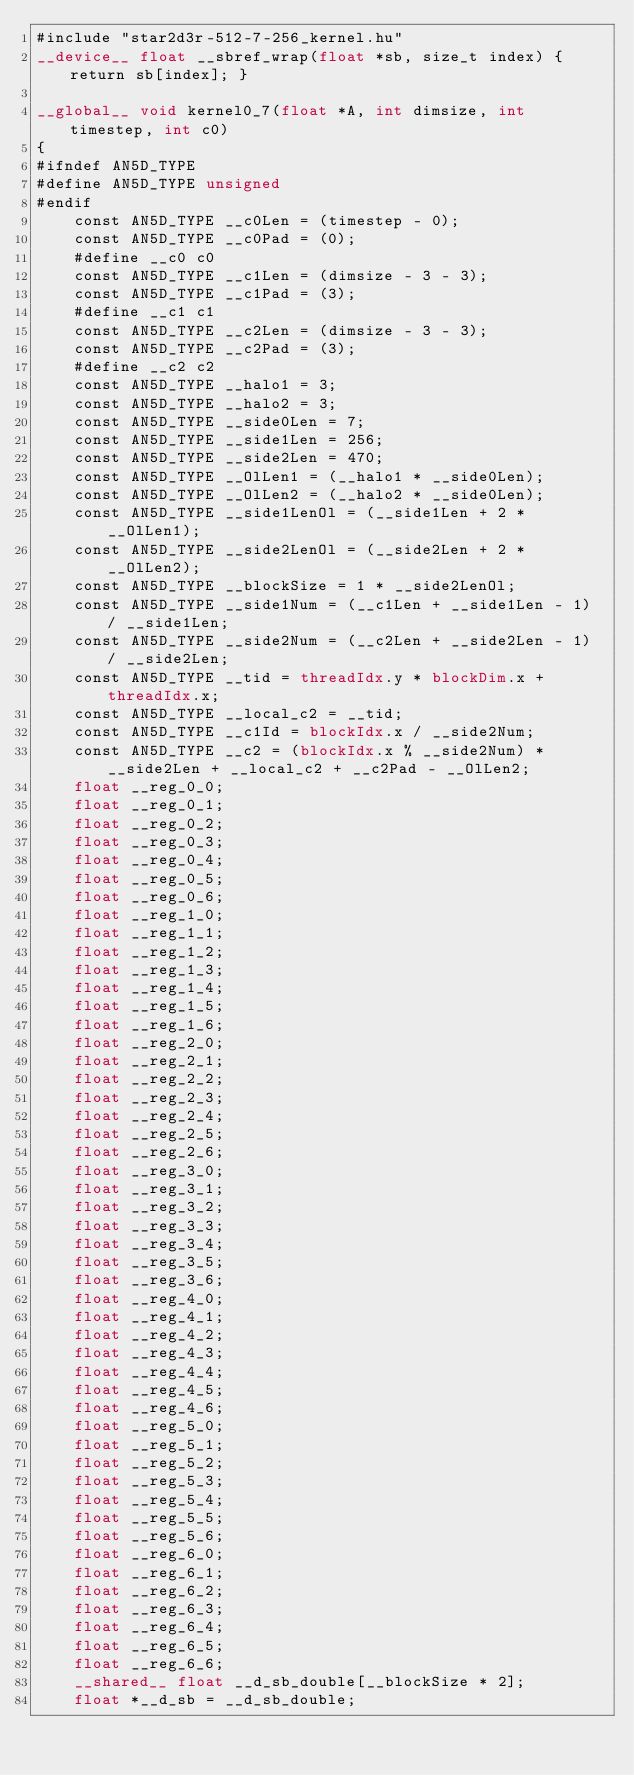<code> <loc_0><loc_0><loc_500><loc_500><_Cuda_>#include "star2d3r-512-7-256_kernel.hu"
__device__ float __sbref_wrap(float *sb, size_t index) { return sb[index]; }

__global__ void kernel0_7(float *A, int dimsize, int timestep, int c0)
{
#ifndef AN5D_TYPE
#define AN5D_TYPE unsigned
#endif
    const AN5D_TYPE __c0Len = (timestep - 0);
    const AN5D_TYPE __c0Pad = (0);
    #define __c0 c0
    const AN5D_TYPE __c1Len = (dimsize - 3 - 3);
    const AN5D_TYPE __c1Pad = (3);
    #define __c1 c1
    const AN5D_TYPE __c2Len = (dimsize - 3 - 3);
    const AN5D_TYPE __c2Pad = (3);
    #define __c2 c2
    const AN5D_TYPE __halo1 = 3;
    const AN5D_TYPE __halo2 = 3;
    const AN5D_TYPE __side0Len = 7;
    const AN5D_TYPE __side1Len = 256;
    const AN5D_TYPE __side2Len = 470;
    const AN5D_TYPE __OlLen1 = (__halo1 * __side0Len);
    const AN5D_TYPE __OlLen2 = (__halo2 * __side0Len);
    const AN5D_TYPE __side1LenOl = (__side1Len + 2 * __OlLen1);
    const AN5D_TYPE __side2LenOl = (__side2Len + 2 * __OlLen2);
    const AN5D_TYPE __blockSize = 1 * __side2LenOl;
    const AN5D_TYPE __side1Num = (__c1Len + __side1Len - 1) / __side1Len;
    const AN5D_TYPE __side2Num = (__c2Len + __side2Len - 1) / __side2Len;
    const AN5D_TYPE __tid = threadIdx.y * blockDim.x + threadIdx.x;
    const AN5D_TYPE __local_c2 = __tid;
    const AN5D_TYPE __c1Id = blockIdx.x / __side2Num;
    const AN5D_TYPE __c2 = (blockIdx.x % __side2Num) * __side2Len + __local_c2 + __c2Pad - __OlLen2;
    float __reg_0_0;
    float __reg_0_1;
    float __reg_0_2;
    float __reg_0_3;
    float __reg_0_4;
    float __reg_0_5;
    float __reg_0_6;
    float __reg_1_0;
    float __reg_1_1;
    float __reg_1_2;
    float __reg_1_3;
    float __reg_1_4;
    float __reg_1_5;
    float __reg_1_6;
    float __reg_2_0;
    float __reg_2_1;
    float __reg_2_2;
    float __reg_2_3;
    float __reg_2_4;
    float __reg_2_5;
    float __reg_2_6;
    float __reg_3_0;
    float __reg_3_1;
    float __reg_3_2;
    float __reg_3_3;
    float __reg_3_4;
    float __reg_3_5;
    float __reg_3_6;
    float __reg_4_0;
    float __reg_4_1;
    float __reg_4_2;
    float __reg_4_3;
    float __reg_4_4;
    float __reg_4_5;
    float __reg_4_6;
    float __reg_5_0;
    float __reg_5_1;
    float __reg_5_2;
    float __reg_5_3;
    float __reg_5_4;
    float __reg_5_5;
    float __reg_5_6;
    float __reg_6_0;
    float __reg_6_1;
    float __reg_6_2;
    float __reg_6_3;
    float __reg_6_4;
    float __reg_6_5;
    float __reg_6_6;
    __shared__ float __d_sb_double[__blockSize * 2];
    float *__d_sb = __d_sb_double;</code> 